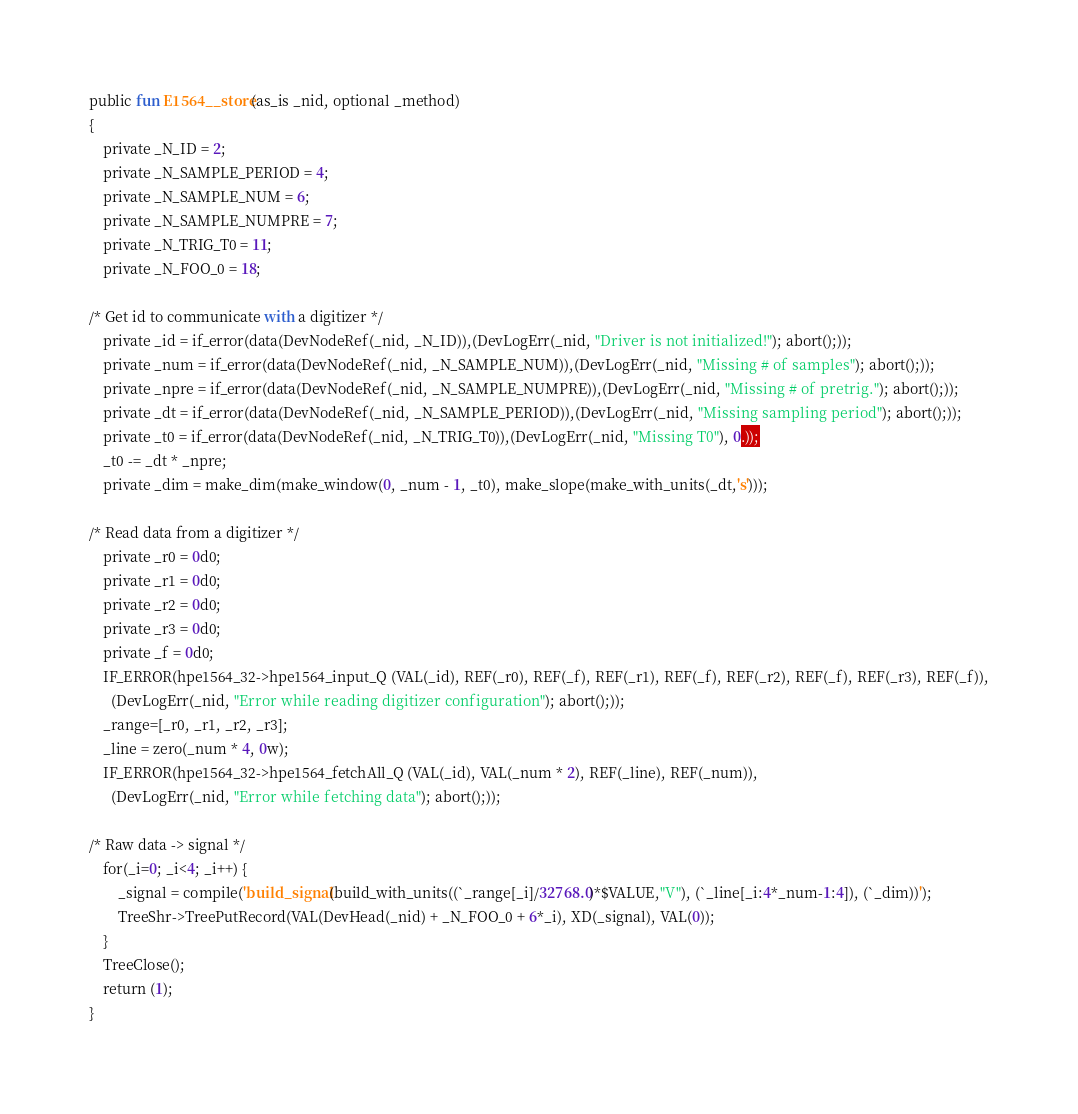Convert code to text. <code><loc_0><loc_0><loc_500><loc_500><_SML_>public fun E1564__store(as_is _nid, optional _method)
{
    private _N_ID = 2;
    private _N_SAMPLE_PERIOD = 4;
    private _N_SAMPLE_NUM = 6;
    private _N_SAMPLE_NUMPRE = 7;
    private _N_TRIG_T0 = 11;
    private _N_FOO_0 = 18;

/* Get id to communicate with a digitizer */
    private _id = if_error(data(DevNodeRef(_nid, _N_ID)),(DevLogErr(_nid, "Driver is not initialized!"); abort();));
    private _num = if_error(data(DevNodeRef(_nid, _N_SAMPLE_NUM)),(DevLogErr(_nid, "Missing # of samples"); abort();));
    private _npre = if_error(data(DevNodeRef(_nid, _N_SAMPLE_NUMPRE)),(DevLogErr(_nid, "Missing # of pretrig."); abort();));
    private _dt = if_error(data(DevNodeRef(_nid, _N_SAMPLE_PERIOD)),(DevLogErr(_nid, "Missing sampling period"); abort();));
    private _t0 = if_error(data(DevNodeRef(_nid, _N_TRIG_T0)),(DevLogErr(_nid, "Missing T0"), 0.));
    _t0 -= _dt * _npre;
    private _dim = make_dim(make_window(0, _num - 1, _t0), make_slope(make_with_units(_dt,'s')));

/* Read data from a digitizer */
    private _r0 = 0d0;
    private _r1 = 0d0;
    private _r2 = 0d0;
    private _r3 = 0d0;
    private _f = 0d0;
    IF_ERROR(hpe1564_32->hpe1564_input_Q (VAL(_id), REF(_r0), REF(_f), REF(_r1), REF(_f), REF(_r2), REF(_f), REF(_r3), REF(_f)),
      (DevLogErr(_nid, "Error while reading digitizer configuration"); abort();));
    _range=[_r0, _r1, _r2, _r3];
    _line = zero(_num * 4, 0w);
    IF_ERROR(hpe1564_32->hpe1564_fetchAll_Q (VAL(_id), VAL(_num * 2), REF(_line), REF(_num)),
      (DevLogErr(_nid, "Error while fetching data"); abort();));

/* Raw data -> signal */
    for(_i=0; _i<4; _i++) {
        _signal = compile('build_signal(build_with_units((`_range[_i]/32768.0)*$VALUE,"V"), (`_line[_i:4*_num-1:4]), (`_dim))');
        TreeShr->TreePutRecord(VAL(DevHead(_nid) + _N_FOO_0 + 6*_i), XD(_signal), VAL(0));
    }
    TreeClose();
    return (1);
}

</code> 